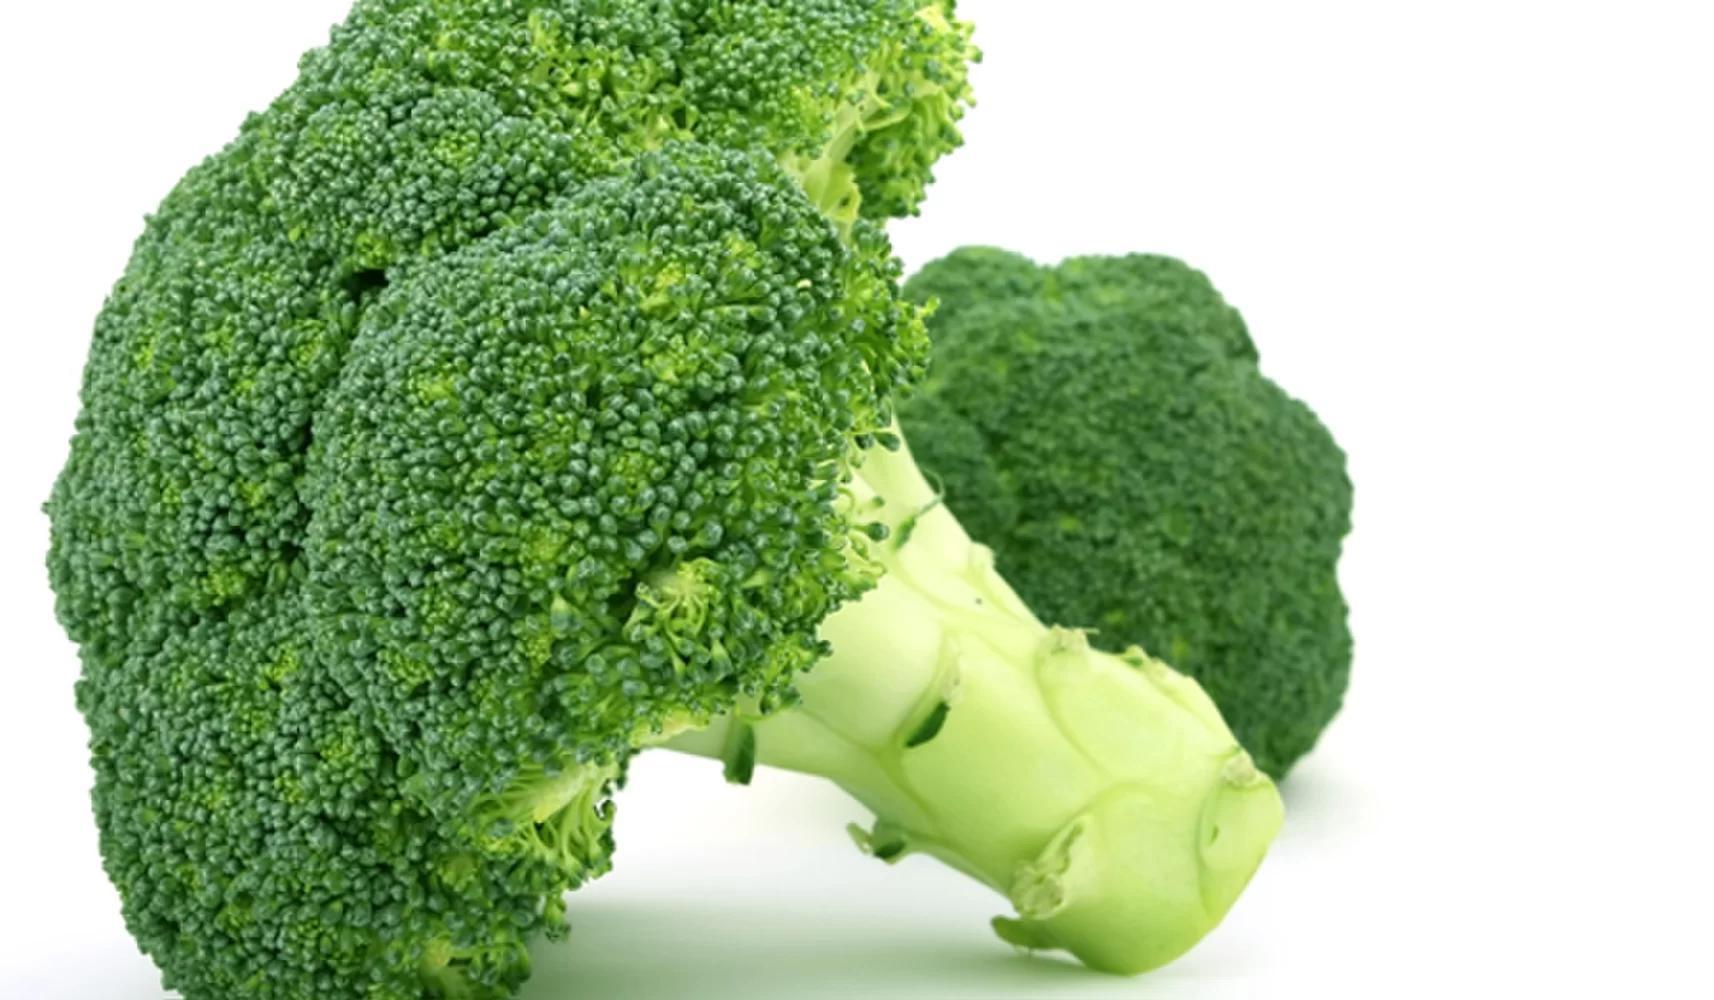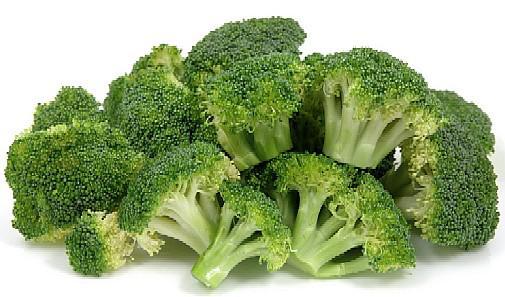The first image is the image on the left, the second image is the image on the right. Examine the images to the left and right. Is the description "An image shows a white bowl that contains some broccoli stalks." accurate? Answer yes or no. No. The first image is the image on the left, the second image is the image on the right. Examine the images to the left and right. Is the description "The broccoli in the image on the right is in a white bowl." accurate? Answer yes or no. No. 